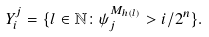Convert formula to latex. <formula><loc_0><loc_0><loc_500><loc_500>Y ^ { j } _ { i } = \{ l \in \mathbb { N } \colon \psi _ { j } ^ { M _ { h ( l ) } } > i / 2 ^ { n } \} .</formula> 